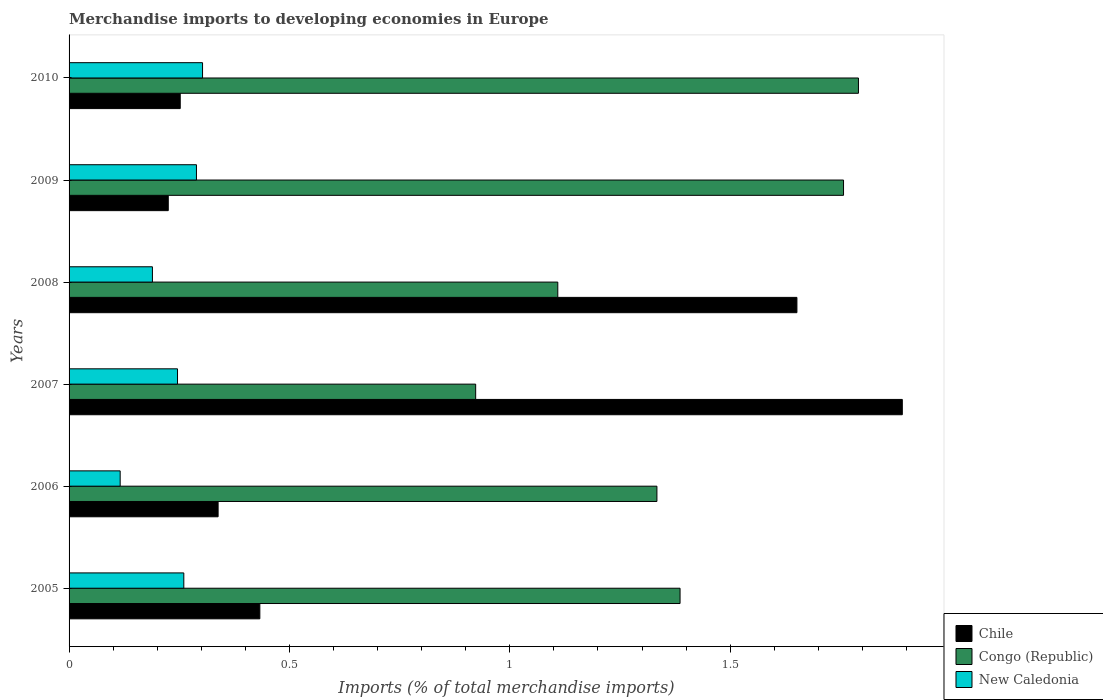How many different coloured bars are there?
Make the answer very short. 3. How many groups of bars are there?
Your response must be concise. 6. Are the number of bars on each tick of the Y-axis equal?
Ensure brevity in your answer.  Yes. How many bars are there on the 5th tick from the bottom?
Make the answer very short. 3. What is the percentage total merchandise imports in Chile in 2010?
Give a very brief answer. 0.25. Across all years, what is the maximum percentage total merchandise imports in Congo (Republic)?
Give a very brief answer. 1.79. Across all years, what is the minimum percentage total merchandise imports in Chile?
Give a very brief answer. 0.23. In which year was the percentage total merchandise imports in Chile minimum?
Offer a terse response. 2009. What is the total percentage total merchandise imports in Chile in the graph?
Give a very brief answer. 4.79. What is the difference between the percentage total merchandise imports in Congo (Republic) in 2005 and that in 2007?
Offer a terse response. 0.46. What is the difference between the percentage total merchandise imports in Congo (Republic) in 2006 and the percentage total merchandise imports in New Caledonia in 2007?
Ensure brevity in your answer.  1.09. What is the average percentage total merchandise imports in Chile per year?
Keep it short and to the point. 0.8. In the year 2010, what is the difference between the percentage total merchandise imports in Congo (Republic) and percentage total merchandise imports in Chile?
Provide a short and direct response. 1.54. In how many years, is the percentage total merchandise imports in Chile greater than 0.4 %?
Provide a short and direct response. 3. What is the ratio of the percentage total merchandise imports in Congo (Republic) in 2007 to that in 2009?
Your answer should be compact. 0.53. Is the percentage total merchandise imports in Chile in 2006 less than that in 2008?
Ensure brevity in your answer.  Yes. Is the difference between the percentage total merchandise imports in Congo (Republic) in 2008 and 2009 greater than the difference between the percentage total merchandise imports in Chile in 2008 and 2009?
Provide a short and direct response. No. What is the difference between the highest and the second highest percentage total merchandise imports in New Caledonia?
Provide a short and direct response. 0.01. What is the difference between the highest and the lowest percentage total merchandise imports in Chile?
Your answer should be compact. 1.67. In how many years, is the percentage total merchandise imports in New Caledonia greater than the average percentage total merchandise imports in New Caledonia taken over all years?
Make the answer very short. 4. What does the 1st bar from the top in 2005 represents?
Provide a succinct answer. New Caledonia. What does the 3rd bar from the bottom in 2007 represents?
Keep it short and to the point. New Caledonia. Is it the case that in every year, the sum of the percentage total merchandise imports in Chile and percentage total merchandise imports in Congo (Republic) is greater than the percentage total merchandise imports in New Caledonia?
Your answer should be compact. Yes. Are all the bars in the graph horizontal?
Offer a very short reply. Yes. How many years are there in the graph?
Your answer should be very brief. 6. Are the values on the major ticks of X-axis written in scientific E-notation?
Your answer should be compact. No. Where does the legend appear in the graph?
Make the answer very short. Bottom right. What is the title of the graph?
Make the answer very short. Merchandise imports to developing economies in Europe. Does "Slovenia" appear as one of the legend labels in the graph?
Your answer should be compact. No. What is the label or title of the X-axis?
Provide a short and direct response. Imports (% of total merchandise imports). What is the Imports (% of total merchandise imports) of Chile in 2005?
Ensure brevity in your answer.  0.43. What is the Imports (% of total merchandise imports) of Congo (Republic) in 2005?
Make the answer very short. 1.39. What is the Imports (% of total merchandise imports) in New Caledonia in 2005?
Make the answer very short. 0.26. What is the Imports (% of total merchandise imports) in Chile in 2006?
Offer a very short reply. 0.34. What is the Imports (% of total merchandise imports) of Congo (Republic) in 2006?
Keep it short and to the point. 1.33. What is the Imports (% of total merchandise imports) in New Caledonia in 2006?
Provide a short and direct response. 0.12. What is the Imports (% of total merchandise imports) of Chile in 2007?
Your answer should be compact. 1.89. What is the Imports (% of total merchandise imports) of Congo (Republic) in 2007?
Your response must be concise. 0.92. What is the Imports (% of total merchandise imports) in New Caledonia in 2007?
Keep it short and to the point. 0.25. What is the Imports (% of total merchandise imports) of Chile in 2008?
Your answer should be very brief. 1.65. What is the Imports (% of total merchandise imports) of Congo (Republic) in 2008?
Offer a very short reply. 1.11. What is the Imports (% of total merchandise imports) in New Caledonia in 2008?
Give a very brief answer. 0.19. What is the Imports (% of total merchandise imports) of Chile in 2009?
Provide a short and direct response. 0.23. What is the Imports (% of total merchandise imports) of Congo (Republic) in 2009?
Keep it short and to the point. 1.76. What is the Imports (% of total merchandise imports) in New Caledonia in 2009?
Give a very brief answer. 0.29. What is the Imports (% of total merchandise imports) in Chile in 2010?
Keep it short and to the point. 0.25. What is the Imports (% of total merchandise imports) of Congo (Republic) in 2010?
Keep it short and to the point. 1.79. What is the Imports (% of total merchandise imports) in New Caledonia in 2010?
Offer a very short reply. 0.3. Across all years, what is the maximum Imports (% of total merchandise imports) in Chile?
Offer a terse response. 1.89. Across all years, what is the maximum Imports (% of total merchandise imports) in Congo (Republic)?
Provide a succinct answer. 1.79. Across all years, what is the maximum Imports (% of total merchandise imports) of New Caledonia?
Keep it short and to the point. 0.3. Across all years, what is the minimum Imports (% of total merchandise imports) of Chile?
Your answer should be compact. 0.23. Across all years, what is the minimum Imports (% of total merchandise imports) of Congo (Republic)?
Your answer should be compact. 0.92. Across all years, what is the minimum Imports (% of total merchandise imports) in New Caledonia?
Offer a terse response. 0.12. What is the total Imports (% of total merchandise imports) of Chile in the graph?
Provide a succinct answer. 4.79. What is the total Imports (% of total merchandise imports) of Congo (Republic) in the graph?
Offer a very short reply. 8.3. What is the total Imports (% of total merchandise imports) of New Caledonia in the graph?
Offer a very short reply. 1.4. What is the difference between the Imports (% of total merchandise imports) in Chile in 2005 and that in 2006?
Offer a very short reply. 0.09. What is the difference between the Imports (% of total merchandise imports) in Congo (Republic) in 2005 and that in 2006?
Ensure brevity in your answer.  0.05. What is the difference between the Imports (% of total merchandise imports) of New Caledonia in 2005 and that in 2006?
Give a very brief answer. 0.14. What is the difference between the Imports (% of total merchandise imports) in Chile in 2005 and that in 2007?
Your response must be concise. -1.46. What is the difference between the Imports (% of total merchandise imports) of Congo (Republic) in 2005 and that in 2007?
Offer a very short reply. 0.46. What is the difference between the Imports (% of total merchandise imports) in New Caledonia in 2005 and that in 2007?
Offer a terse response. 0.01. What is the difference between the Imports (% of total merchandise imports) in Chile in 2005 and that in 2008?
Keep it short and to the point. -1.22. What is the difference between the Imports (% of total merchandise imports) in Congo (Republic) in 2005 and that in 2008?
Provide a short and direct response. 0.28. What is the difference between the Imports (% of total merchandise imports) in New Caledonia in 2005 and that in 2008?
Your response must be concise. 0.07. What is the difference between the Imports (% of total merchandise imports) in Chile in 2005 and that in 2009?
Provide a short and direct response. 0.21. What is the difference between the Imports (% of total merchandise imports) in Congo (Republic) in 2005 and that in 2009?
Your answer should be very brief. -0.37. What is the difference between the Imports (% of total merchandise imports) of New Caledonia in 2005 and that in 2009?
Provide a short and direct response. -0.03. What is the difference between the Imports (% of total merchandise imports) in Chile in 2005 and that in 2010?
Offer a terse response. 0.18. What is the difference between the Imports (% of total merchandise imports) of Congo (Republic) in 2005 and that in 2010?
Give a very brief answer. -0.4. What is the difference between the Imports (% of total merchandise imports) in New Caledonia in 2005 and that in 2010?
Provide a short and direct response. -0.04. What is the difference between the Imports (% of total merchandise imports) of Chile in 2006 and that in 2007?
Keep it short and to the point. -1.55. What is the difference between the Imports (% of total merchandise imports) of Congo (Republic) in 2006 and that in 2007?
Make the answer very short. 0.41. What is the difference between the Imports (% of total merchandise imports) in New Caledonia in 2006 and that in 2007?
Make the answer very short. -0.13. What is the difference between the Imports (% of total merchandise imports) in Chile in 2006 and that in 2008?
Your answer should be very brief. -1.31. What is the difference between the Imports (% of total merchandise imports) in Congo (Republic) in 2006 and that in 2008?
Give a very brief answer. 0.22. What is the difference between the Imports (% of total merchandise imports) of New Caledonia in 2006 and that in 2008?
Keep it short and to the point. -0.07. What is the difference between the Imports (% of total merchandise imports) of Chile in 2006 and that in 2009?
Your answer should be very brief. 0.11. What is the difference between the Imports (% of total merchandise imports) of Congo (Republic) in 2006 and that in 2009?
Give a very brief answer. -0.42. What is the difference between the Imports (% of total merchandise imports) in New Caledonia in 2006 and that in 2009?
Provide a short and direct response. -0.17. What is the difference between the Imports (% of total merchandise imports) of Chile in 2006 and that in 2010?
Ensure brevity in your answer.  0.09. What is the difference between the Imports (% of total merchandise imports) in Congo (Republic) in 2006 and that in 2010?
Offer a terse response. -0.46. What is the difference between the Imports (% of total merchandise imports) in New Caledonia in 2006 and that in 2010?
Provide a short and direct response. -0.19. What is the difference between the Imports (% of total merchandise imports) of Chile in 2007 and that in 2008?
Provide a succinct answer. 0.24. What is the difference between the Imports (% of total merchandise imports) of Congo (Republic) in 2007 and that in 2008?
Offer a very short reply. -0.19. What is the difference between the Imports (% of total merchandise imports) in New Caledonia in 2007 and that in 2008?
Offer a very short reply. 0.06. What is the difference between the Imports (% of total merchandise imports) of Chile in 2007 and that in 2009?
Your answer should be very brief. 1.67. What is the difference between the Imports (% of total merchandise imports) of Congo (Republic) in 2007 and that in 2009?
Give a very brief answer. -0.83. What is the difference between the Imports (% of total merchandise imports) of New Caledonia in 2007 and that in 2009?
Provide a short and direct response. -0.04. What is the difference between the Imports (% of total merchandise imports) in Chile in 2007 and that in 2010?
Offer a very short reply. 1.64. What is the difference between the Imports (% of total merchandise imports) of Congo (Republic) in 2007 and that in 2010?
Keep it short and to the point. -0.87. What is the difference between the Imports (% of total merchandise imports) in New Caledonia in 2007 and that in 2010?
Offer a terse response. -0.06. What is the difference between the Imports (% of total merchandise imports) of Chile in 2008 and that in 2009?
Provide a succinct answer. 1.43. What is the difference between the Imports (% of total merchandise imports) of Congo (Republic) in 2008 and that in 2009?
Provide a succinct answer. -0.65. What is the difference between the Imports (% of total merchandise imports) in New Caledonia in 2008 and that in 2009?
Make the answer very short. -0.1. What is the difference between the Imports (% of total merchandise imports) in Chile in 2008 and that in 2010?
Offer a very short reply. 1.4. What is the difference between the Imports (% of total merchandise imports) of Congo (Republic) in 2008 and that in 2010?
Provide a succinct answer. -0.68. What is the difference between the Imports (% of total merchandise imports) of New Caledonia in 2008 and that in 2010?
Your answer should be compact. -0.11. What is the difference between the Imports (% of total merchandise imports) of Chile in 2009 and that in 2010?
Your answer should be compact. -0.03. What is the difference between the Imports (% of total merchandise imports) in Congo (Republic) in 2009 and that in 2010?
Make the answer very short. -0.03. What is the difference between the Imports (% of total merchandise imports) in New Caledonia in 2009 and that in 2010?
Give a very brief answer. -0.01. What is the difference between the Imports (% of total merchandise imports) of Chile in 2005 and the Imports (% of total merchandise imports) of Congo (Republic) in 2006?
Provide a short and direct response. -0.9. What is the difference between the Imports (% of total merchandise imports) in Chile in 2005 and the Imports (% of total merchandise imports) in New Caledonia in 2006?
Give a very brief answer. 0.32. What is the difference between the Imports (% of total merchandise imports) in Congo (Republic) in 2005 and the Imports (% of total merchandise imports) in New Caledonia in 2006?
Ensure brevity in your answer.  1.27. What is the difference between the Imports (% of total merchandise imports) of Chile in 2005 and the Imports (% of total merchandise imports) of Congo (Republic) in 2007?
Your response must be concise. -0.49. What is the difference between the Imports (% of total merchandise imports) of Chile in 2005 and the Imports (% of total merchandise imports) of New Caledonia in 2007?
Provide a short and direct response. 0.19. What is the difference between the Imports (% of total merchandise imports) in Congo (Republic) in 2005 and the Imports (% of total merchandise imports) in New Caledonia in 2007?
Offer a terse response. 1.14. What is the difference between the Imports (% of total merchandise imports) in Chile in 2005 and the Imports (% of total merchandise imports) in Congo (Republic) in 2008?
Offer a very short reply. -0.68. What is the difference between the Imports (% of total merchandise imports) in Chile in 2005 and the Imports (% of total merchandise imports) in New Caledonia in 2008?
Your answer should be very brief. 0.24. What is the difference between the Imports (% of total merchandise imports) in Congo (Republic) in 2005 and the Imports (% of total merchandise imports) in New Caledonia in 2008?
Make the answer very short. 1.2. What is the difference between the Imports (% of total merchandise imports) of Chile in 2005 and the Imports (% of total merchandise imports) of Congo (Republic) in 2009?
Provide a succinct answer. -1.32. What is the difference between the Imports (% of total merchandise imports) in Chile in 2005 and the Imports (% of total merchandise imports) in New Caledonia in 2009?
Ensure brevity in your answer.  0.14. What is the difference between the Imports (% of total merchandise imports) in Congo (Republic) in 2005 and the Imports (% of total merchandise imports) in New Caledonia in 2009?
Ensure brevity in your answer.  1.1. What is the difference between the Imports (% of total merchandise imports) of Chile in 2005 and the Imports (% of total merchandise imports) of Congo (Republic) in 2010?
Give a very brief answer. -1.36. What is the difference between the Imports (% of total merchandise imports) of Chile in 2005 and the Imports (% of total merchandise imports) of New Caledonia in 2010?
Ensure brevity in your answer.  0.13. What is the difference between the Imports (% of total merchandise imports) of Congo (Republic) in 2005 and the Imports (% of total merchandise imports) of New Caledonia in 2010?
Your answer should be very brief. 1.08. What is the difference between the Imports (% of total merchandise imports) in Chile in 2006 and the Imports (% of total merchandise imports) in Congo (Republic) in 2007?
Keep it short and to the point. -0.58. What is the difference between the Imports (% of total merchandise imports) in Chile in 2006 and the Imports (% of total merchandise imports) in New Caledonia in 2007?
Make the answer very short. 0.09. What is the difference between the Imports (% of total merchandise imports) in Congo (Republic) in 2006 and the Imports (% of total merchandise imports) in New Caledonia in 2007?
Provide a short and direct response. 1.09. What is the difference between the Imports (% of total merchandise imports) in Chile in 2006 and the Imports (% of total merchandise imports) in Congo (Republic) in 2008?
Your answer should be compact. -0.77. What is the difference between the Imports (% of total merchandise imports) in Chile in 2006 and the Imports (% of total merchandise imports) in New Caledonia in 2008?
Offer a very short reply. 0.15. What is the difference between the Imports (% of total merchandise imports) of Congo (Republic) in 2006 and the Imports (% of total merchandise imports) of New Caledonia in 2008?
Keep it short and to the point. 1.14. What is the difference between the Imports (% of total merchandise imports) in Chile in 2006 and the Imports (% of total merchandise imports) in Congo (Republic) in 2009?
Give a very brief answer. -1.42. What is the difference between the Imports (% of total merchandise imports) in Chile in 2006 and the Imports (% of total merchandise imports) in New Caledonia in 2009?
Your answer should be very brief. 0.05. What is the difference between the Imports (% of total merchandise imports) in Congo (Republic) in 2006 and the Imports (% of total merchandise imports) in New Caledonia in 2009?
Provide a succinct answer. 1.04. What is the difference between the Imports (% of total merchandise imports) of Chile in 2006 and the Imports (% of total merchandise imports) of Congo (Republic) in 2010?
Offer a terse response. -1.45. What is the difference between the Imports (% of total merchandise imports) of Chile in 2006 and the Imports (% of total merchandise imports) of New Caledonia in 2010?
Offer a very short reply. 0.04. What is the difference between the Imports (% of total merchandise imports) of Congo (Republic) in 2006 and the Imports (% of total merchandise imports) of New Caledonia in 2010?
Your answer should be compact. 1.03. What is the difference between the Imports (% of total merchandise imports) in Chile in 2007 and the Imports (% of total merchandise imports) in Congo (Republic) in 2008?
Your response must be concise. 0.78. What is the difference between the Imports (% of total merchandise imports) of Chile in 2007 and the Imports (% of total merchandise imports) of New Caledonia in 2008?
Offer a terse response. 1.7. What is the difference between the Imports (% of total merchandise imports) of Congo (Republic) in 2007 and the Imports (% of total merchandise imports) of New Caledonia in 2008?
Your response must be concise. 0.73. What is the difference between the Imports (% of total merchandise imports) of Chile in 2007 and the Imports (% of total merchandise imports) of Congo (Republic) in 2009?
Make the answer very short. 0.13. What is the difference between the Imports (% of total merchandise imports) in Chile in 2007 and the Imports (% of total merchandise imports) in New Caledonia in 2009?
Your response must be concise. 1.6. What is the difference between the Imports (% of total merchandise imports) of Congo (Republic) in 2007 and the Imports (% of total merchandise imports) of New Caledonia in 2009?
Keep it short and to the point. 0.63. What is the difference between the Imports (% of total merchandise imports) of Chile in 2007 and the Imports (% of total merchandise imports) of Congo (Republic) in 2010?
Provide a short and direct response. 0.1. What is the difference between the Imports (% of total merchandise imports) of Chile in 2007 and the Imports (% of total merchandise imports) of New Caledonia in 2010?
Offer a very short reply. 1.59. What is the difference between the Imports (% of total merchandise imports) in Congo (Republic) in 2007 and the Imports (% of total merchandise imports) in New Caledonia in 2010?
Provide a short and direct response. 0.62. What is the difference between the Imports (% of total merchandise imports) in Chile in 2008 and the Imports (% of total merchandise imports) in Congo (Republic) in 2009?
Your answer should be very brief. -0.11. What is the difference between the Imports (% of total merchandise imports) in Chile in 2008 and the Imports (% of total merchandise imports) in New Caledonia in 2009?
Your answer should be very brief. 1.36. What is the difference between the Imports (% of total merchandise imports) in Congo (Republic) in 2008 and the Imports (% of total merchandise imports) in New Caledonia in 2009?
Give a very brief answer. 0.82. What is the difference between the Imports (% of total merchandise imports) in Chile in 2008 and the Imports (% of total merchandise imports) in Congo (Republic) in 2010?
Give a very brief answer. -0.14. What is the difference between the Imports (% of total merchandise imports) of Chile in 2008 and the Imports (% of total merchandise imports) of New Caledonia in 2010?
Ensure brevity in your answer.  1.35. What is the difference between the Imports (% of total merchandise imports) of Congo (Republic) in 2008 and the Imports (% of total merchandise imports) of New Caledonia in 2010?
Offer a very short reply. 0.81. What is the difference between the Imports (% of total merchandise imports) of Chile in 2009 and the Imports (% of total merchandise imports) of Congo (Republic) in 2010?
Make the answer very short. -1.57. What is the difference between the Imports (% of total merchandise imports) in Chile in 2009 and the Imports (% of total merchandise imports) in New Caledonia in 2010?
Keep it short and to the point. -0.08. What is the difference between the Imports (% of total merchandise imports) in Congo (Republic) in 2009 and the Imports (% of total merchandise imports) in New Caledonia in 2010?
Your answer should be very brief. 1.45. What is the average Imports (% of total merchandise imports) of Chile per year?
Provide a short and direct response. 0.8. What is the average Imports (% of total merchandise imports) of Congo (Republic) per year?
Provide a short and direct response. 1.38. What is the average Imports (% of total merchandise imports) in New Caledonia per year?
Provide a succinct answer. 0.23. In the year 2005, what is the difference between the Imports (% of total merchandise imports) in Chile and Imports (% of total merchandise imports) in Congo (Republic)?
Your answer should be very brief. -0.95. In the year 2005, what is the difference between the Imports (% of total merchandise imports) in Chile and Imports (% of total merchandise imports) in New Caledonia?
Ensure brevity in your answer.  0.17. In the year 2005, what is the difference between the Imports (% of total merchandise imports) in Congo (Republic) and Imports (% of total merchandise imports) in New Caledonia?
Make the answer very short. 1.13. In the year 2006, what is the difference between the Imports (% of total merchandise imports) of Chile and Imports (% of total merchandise imports) of Congo (Republic)?
Your answer should be compact. -1. In the year 2006, what is the difference between the Imports (% of total merchandise imports) in Chile and Imports (% of total merchandise imports) in New Caledonia?
Give a very brief answer. 0.22. In the year 2006, what is the difference between the Imports (% of total merchandise imports) of Congo (Republic) and Imports (% of total merchandise imports) of New Caledonia?
Make the answer very short. 1.22. In the year 2007, what is the difference between the Imports (% of total merchandise imports) in Chile and Imports (% of total merchandise imports) in Congo (Republic)?
Provide a succinct answer. 0.97. In the year 2007, what is the difference between the Imports (% of total merchandise imports) of Chile and Imports (% of total merchandise imports) of New Caledonia?
Your answer should be compact. 1.64. In the year 2007, what is the difference between the Imports (% of total merchandise imports) of Congo (Republic) and Imports (% of total merchandise imports) of New Caledonia?
Ensure brevity in your answer.  0.68. In the year 2008, what is the difference between the Imports (% of total merchandise imports) in Chile and Imports (% of total merchandise imports) in Congo (Republic)?
Keep it short and to the point. 0.54. In the year 2008, what is the difference between the Imports (% of total merchandise imports) of Chile and Imports (% of total merchandise imports) of New Caledonia?
Your answer should be compact. 1.46. In the year 2008, what is the difference between the Imports (% of total merchandise imports) of Congo (Republic) and Imports (% of total merchandise imports) of New Caledonia?
Ensure brevity in your answer.  0.92. In the year 2009, what is the difference between the Imports (% of total merchandise imports) of Chile and Imports (% of total merchandise imports) of Congo (Republic)?
Your answer should be compact. -1.53. In the year 2009, what is the difference between the Imports (% of total merchandise imports) in Chile and Imports (% of total merchandise imports) in New Caledonia?
Provide a short and direct response. -0.06. In the year 2009, what is the difference between the Imports (% of total merchandise imports) in Congo (Republic) and Imports (% of total merchandise imports) in New Caledonia?
Provide a succinct answer. 1.47. In the year 2010, what is the difference between the Imports (% of total merchandise imports) of Chile and Imports (% of total merchandise imports) of Congo (Republic)?
Offer a very short reply. -1.54. In the year 2010, what is the difference between the Imports (% of total merchandise imports) of Chile and Imports (% of total merchandise imports) of New Caledonia?
Offer a terse response. -0.05. In the year 2010, what is the difference between the Imports (% of total merchandise imports) of Congo (Republic) and Imports (% of total merchandise imports) of New Caledonia?
Your answer should be very brief. 1.49. What is the ratio of the Imports (% of total merchandise imports) of Chile in 2005 to that in 2006?
Provide a succinct answer. 1.28. What is the ratio of the Imports (% of total merchandise imports) of Congo (Republic) in 2005 to that in 2006?
Your response must be concise. 1.04. What is the ratio of the Imports (% of total merchandise imports) in New Caledonia in 2005 to that in 2006?
Give a very brief answer. 2.25. What is the ratio of the Imports (% of total merchandise imports) in Chile in 2005 to that in 2007?
Provide a short and direct response. 0.23. What is the ratio of the Imports (% of total merchandise imports) in Congo (Republic) in 2005 to that in 2007?
Make the answer very short. 1.5. What is the ratio of the Imports (% of total merchandise imports) in New Caledonia in 2005 to that in 2007?
Your answer should be very brief. 1.06. What is the ratio of the Imports (% of total merchandise imports) in Chile in 2005 to that in 2008?
Your response must be concise. 0.26. What is the ratio of the Imports (% of total merchandise imports) in Congo (Republic) in 2005 to that in 2008?
Provide a succinct answer. 1.25. What is the ratio of the Imports (% of total merchandise imports) in New Caledonia in 2005 to that in 2008?
Keep it short and to the point. 1.38. What is the ratio of the Imports (% of total merchandise imports) of Chile in 2005 to that in 2009?
Keep it short and to the point. 1.92. What is the ratio of the Imports (% of total merchandise imports) of Congo (Republic) in 2005 to that in 2009?
Offer a very short reply. 0.79. What is the ratio of the Imports (% of total merchandise imports) of New Caledonia in 2005 to that in 2009?
Your response must be concise. 0.9. What is the ratio of the Imports (% of total merchandise imports) in Chile in 2005 to that in 2010?
Give a very brief answer. 1.72. What is the ratio of the Imports (% of total merchandise imports) in Congo (Republic) in 2005 to that in 2010?
Ensure brevity in your answer.  0.77. What is the ratio of the Imports (% of total merchandise imports) in New Caledonia in 2005 to that in 2010?
Ensure brevity in your answer.  0.86. What is the ratio of the Imports (% of total merchandise imports) in Chile in 2006 to that in 2007?
Offer a very short reply. 0.18. What is the ratio of the Imports (% of total merchandise imports) of Congo (Republic) in 2006 to that in 2007?
Your answer should be compact. 1.45. What is the ratio of the Imports (% of total merchandise imports) in New Caledonia in 2006 to that in 2007?
Your answer should be compact. 0.47. What is the ratio of the Imports (% of total merchandise imports) in Chile in 2006 to that in 2008?
Offer a terse response. 0.2. What is the ratio of the Imports (% of total merchandise imports) of Congo (Republic) in 2006 to that in 2008?
Offer a very short reply. 1.2. What is the ratio of the Imports (% of total merchandise imports) in New Caledonia in 2006 to that in 2008?
Your answer should be compact. 0.61. What is the ratio of the Imports (% of total merchandise imports) in Chile in 2006 to that in 2009?
Give a very brief answer. 1.5. What is the ratio of the Imports (% of total merchandise imports) in Congo (Republic) in 2006 to that in 2009?
Ensure brevity in your answer.  0.76. What is the ratio of the Imports (% of total merchandise imports) of New Caledonia in 2006 to that in 2009?
Give a very brief answer. 0.4. What is the ratio of the Imports (% of total merchandise imports) of Chile in 2006 to that in 2010?
Make the answer very short. 1.34. What is the ratio of the Imports (% of total merchandise imports) of Congo (Republic) in 2006 to that in 2010?
Offer a terse response. 0.74. What is the ratio of the Imports (% of total merchandise imports) in New Caledonia in 2006 to that in 2010?
Offer a terse response. 0.38. What is the ratio of the Imports (% of total merchandise imports) in Chile in 2007 to that in 2008?
Provide a succinct answer. 1.14. What is the ratio of the Imports (% of total merchandise imports) of Congo (Republic) in 2007 to that in 2008?
Ensure brevity in your answer.  0.83. What is the ratio of the Imports (% of total merchandise imports) of New Caledonia in 2007 to that in 2008?
Your answer should be very brief. 1.3. What is the ratio of the Imports (% of total merchandise imports) in Chile in 2007 to that in 2009?
Your response must be concise. 8.4. What is the ratio of the Imports (% of total merchandise imports) of Congo (Republic) in 2007 to that in 2009?
Ensure brevity in your answer.  0.53. What is the ratio of the Imports (% of total merchandise imports) of New Caledonia in 2007 to that in 2009?
Keep it short and to the point. 0.85. What is the ratio of the Imports (% of total merchandise imports) in Chile in 2007 to that in 2010?
Your answer should be very brief. 7.5. What is the ratio of the Imports (% of total merchandise imports) of Congo (Republic) in 2007 to that in 2010?
Offer a terse response. 0.52. What is the ratio of the Imports (% of total merchandise imports) of New Caledonia in 2007 to that in 2010?
Ensure brevity in your answer.  0.81. What is the ratio of the Imports (% of total merchandise imports) of Chile in 2008 to that in 2009?
Your answer should be very brief. 7.34. What is the ratio of the Imports (% of total merchandise imports) of Congo (Republic) in 2008 to that in 2009?
Provide a succinct answer. 0.63. What is the ratio of the Imports (% of total merchandise imports) of New Caledonia in 2008 to that in 2009?
Offer a terse response. 0.65. What is the ratio of the Imports (% of total merchandise imports) of Chile in 2008 to that in 2010?
Ensure brevity in your answer.  6.55. What is the ratio of the Imports (% of total merchandise imports) in Congo (Republic) in 2008 to that in 2010?
Your response must be concise. 0.62. What is the ratio of the Imports (% of total merchandise imports) in New Caledonia in 2008 to that in 2010?
Your response must be concise. 0.62. What is the ratio of the Imports (% of total merchandise imports) of Chile in 2009 to that in 2010?
Your response must be concise. 0.89. What is the ratio of the Imports (% of total merchandise imports) in Congo (Republic) in 2009 to that in 2010?
Offer a terse response. 0.98. What is the ratio of the Imports (% of total merchandise imports) of New Caledonia in 2009 to that in 2010?
Your answer should be very brief. 0.95. What is the difference between the highest and the second highest Imports (% of total merchandise imports) in Chile?
Your response must be concise. 0.24. What is the difference between the highest and the second highest Imports (% of total merchandise imports) of Congo (Republic)?
Provide a succinct answer. 0.03. What is the difference between the highest and the second highest Imports (% of total merchandise imports) in New Caledonia?
Offer a terse response. 0.01. What is the difference between the highest and the lowest Imports (% of total merchandise imports) in Chile?
Provide a short and direct response. 1.67. What is the difference between the highest and the lowest Imports (% of total merchandise imports) in Congo (Republic)?
Your response must be concise. 0.87. What is the difference between the highest and the lowest Imports (% of total merchandise imports) of New Caledonia?
Provide a succinct answer. 0.19. 